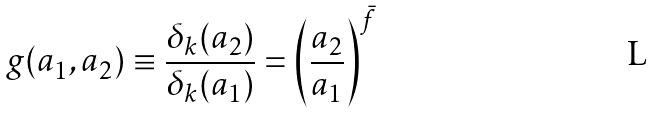Convert formula to latex. <formula><loc_0><loc_0><loc_500><loc_500>g ( a _ { 1 } , a _ { 2 } ) \equiv \frac { \delta _ { k } ( a _ { 2 } ) } { \delta _ { k } ( a _ { 1 } ) } = \left ( \frac { a _ { 2 } } { a _ { 1 } } \right ) ^ { \bar { f } }</formula> 